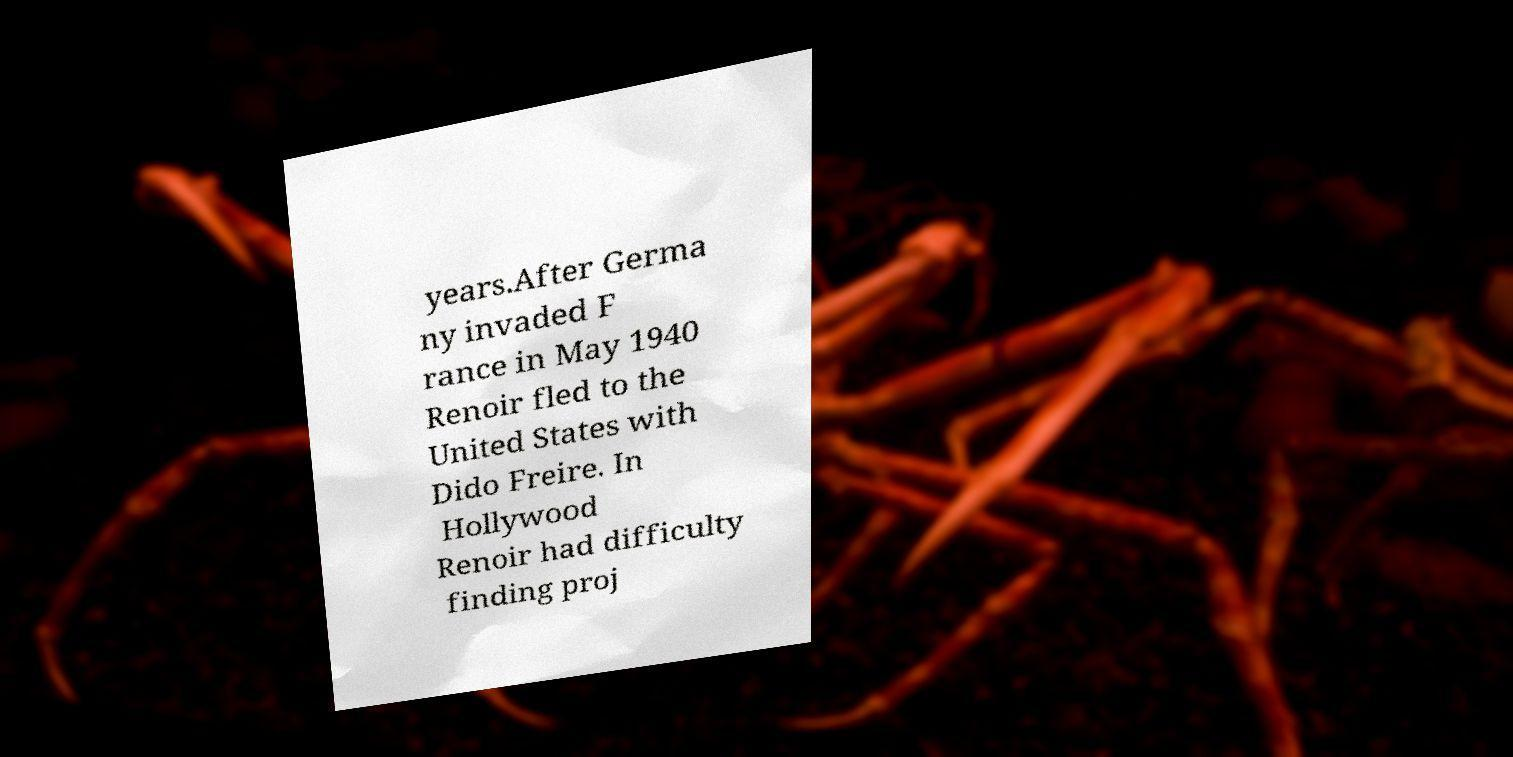What messages or text are displayed in this image? I need them in a readable, typed format. years.After Germa ny invaded F rance in May 1940 Renoir fled to the United States with Dido Freire. In Hollywood Renoir had difficulty finding proj 